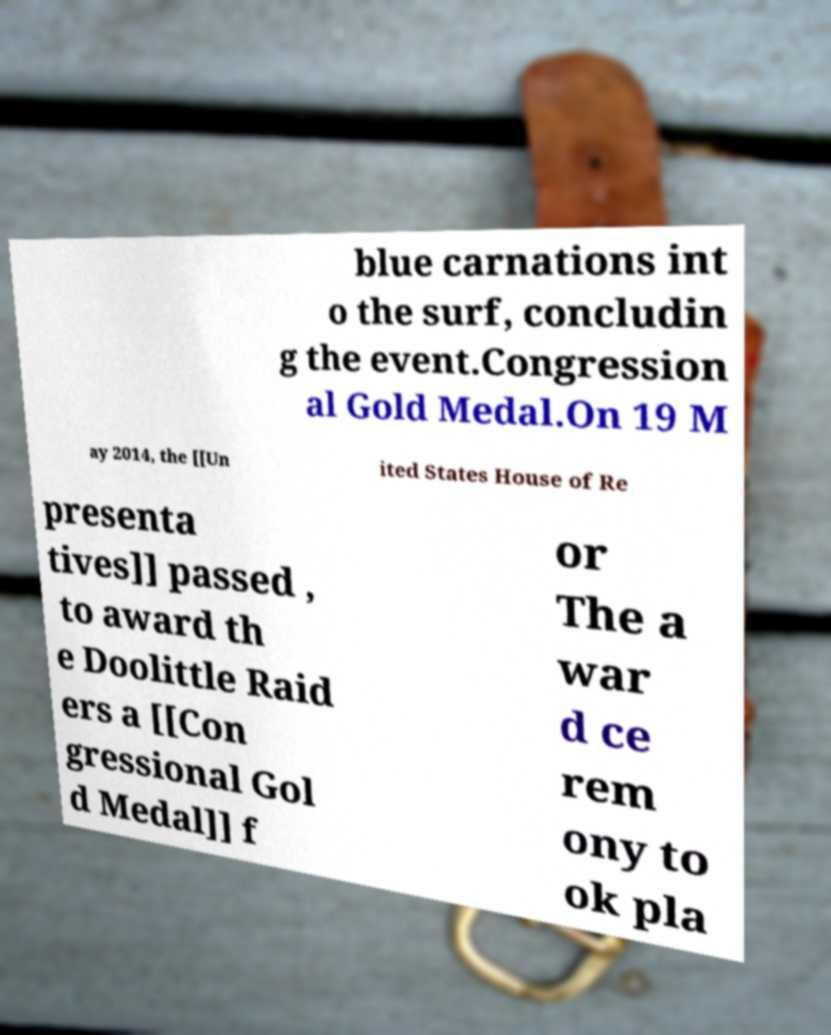Please read and relay the text visible in this image. What does it say? blue carnations int o the surf, concludin g the event.Congression al Gold Medal.On 19 M ay 2014, the [[Un ited States House of Re presenta tives]] passed , to award th e Doolittle Raid ers a [[Con gressional Gol d Medal]] f or The a war d ce rem ony to ok pla 